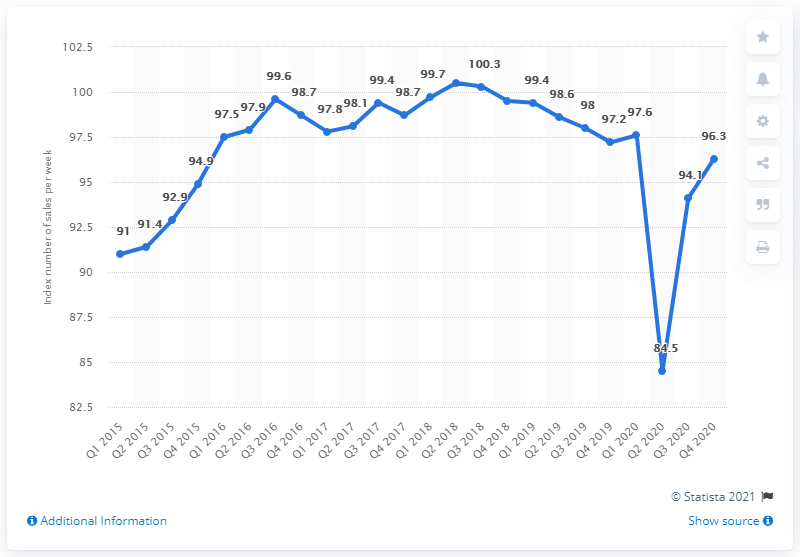Indicate a few pertinent items in this graphic. The index value for department store sales in the second quarter of 2018 was 100.5. 